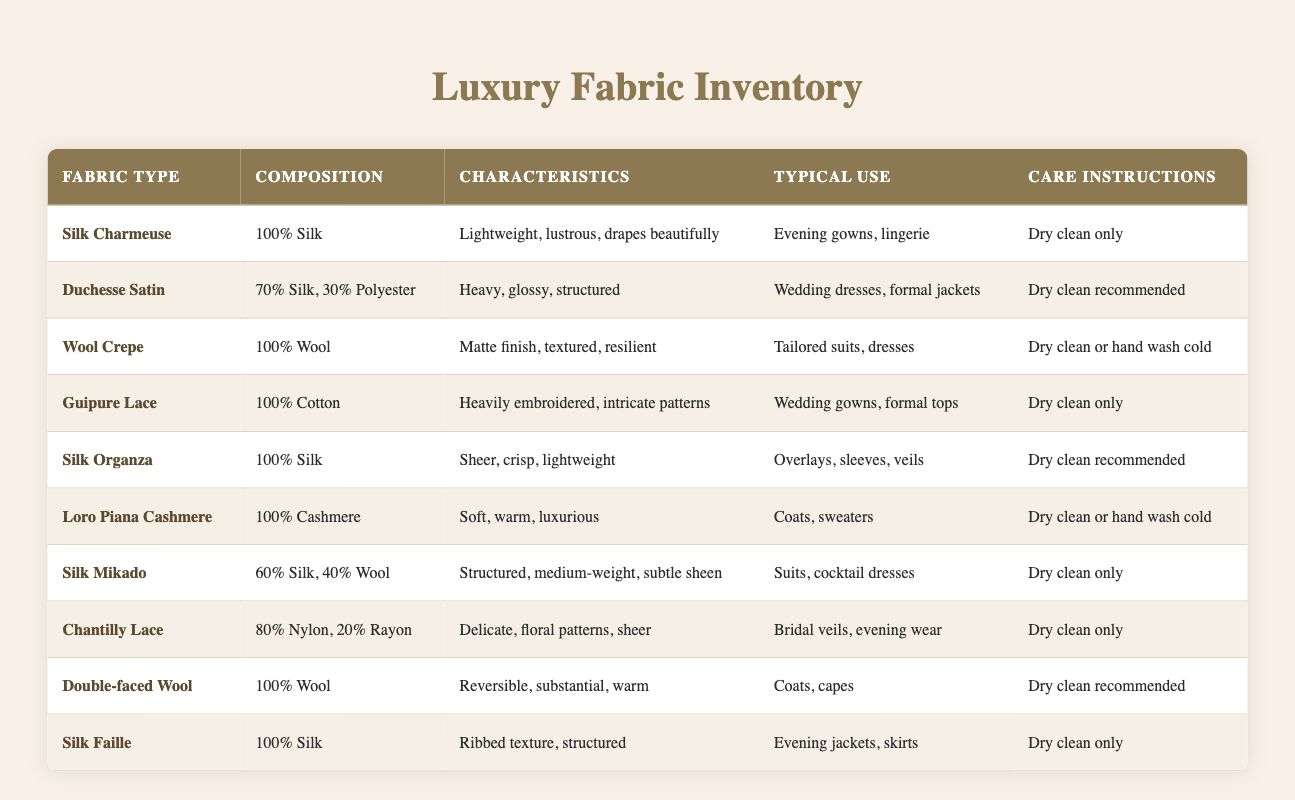What is the typical use of Silk Charmeuse? Silk Charmeuse is listed in the table with the typical uses as "Evening gowns, lingerie." Therefore, we can identify its common applications.
Answer: Evening gowns, lingerie What percentage of Silk Mikado is made of Silk? The table indicates that Silk Mikado is composed of 60% Silk and 40% Wool. This directly provides us with the information needed to answer the question.
Answer: 60% Is Guipure Lace made of synthetic fibers? Guipure Lace is composed of 100% Cotton, which is a natural fiber, not a synthetic one. Therefore, the statement is false.
Answer: No Which fabric type has the characteristic of being "Delicate, floral patterns, sheer"? This description matches Chantilly Lace as per the information provided in the table. Hence, it identifies the correct fabric type.
Answer: Chantilly Lace What care instructions are recommended for Double-faced Wool? The care instructions for Double-faced Wool, according to the table, state "Dry clean recommended." This is how we answer the question based on the specific details available.
Answer: Dry clean recommended What is the average fiber content of the fabrics listed in the table? To find the average, we need to gather the composition percentages from each fabric where applicable. Silk types range from 60-100% and the others primarily consist of wool or cotton. However, to compute an exact average, we would need specific numerical values for all fabric compositions, which are not available as percentages of weight or volume only. Therefore, it's more complex and cannot yield a straightforward numeric average without specifically defined quantities.
Answer: Not available How many fabric types are suitable for use in wedding-related garments? By examining the typical use column in the table, we find that both Guipure Lace and Duchesse Satin are suited for wedding gowns and related formal attire. Therefore, two fabric types fit this category.
Answer: 2 Is Loro Piana Cashmere suitable for formal jackets? The table lists typical uses for Loro Piana Cashmere as "Coats, sweaters," which does not specifically state that it can be used for formal jackets. Therefore, the answer is no.
Answer: No Which fabric is both structured and medium-weight? The description of Silk Mikado in the table specifies that it is "Structured, medium-weight, subtle sheen." This matches both aspects of the inquiry directly from its characteristics.
Answer: Silk Mikado 